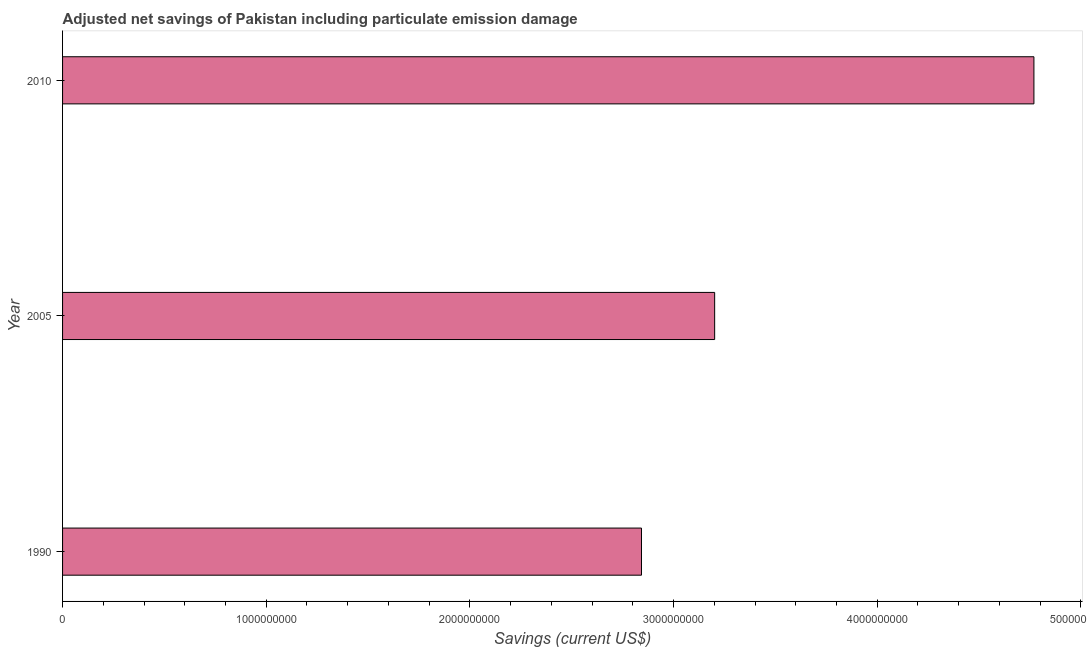Does the graph contain any zero values?
Provide a succinct answer. No. Does the graph contain grids?
Provide a succinct answer. No. What is the title of the graph?
Ensure brevity in your answer.  Adjusted net savings of Pakistan including particulate emission damage. What is the label or title of the X-axis?
Your answer should be very brief. Savings (current US$). What is the adjusted net savings in 2010?
Make the answer very short. 4.77e+09. Across all years, what is the maximum adjusted net savings?
Provide a succinct answer. 4.77e+09. Across all years, what is the minimum adjusted net savings?
Give a very brief answer. 2.84e+09. In which year was the adjusted net savings maximum?
Provide a short and direct response. 2010. What is the sum of the adjusted net savings?
Give a very brief answer. 1.08e+1. What is the difference between the adjusted net savings in 1990 and 2005?
Provide a short and direct response. -3.59e+08. What is the average adjusted net savings per year?
Provide a succinct answer. 3.60e+09. What is the median adjusted net savings?
Give a very brief answer. 3.20e+09. In how many years, is the adjusted net savings greater than 1200000000 US$?
Your answer should be compact. 3. Do a majority of the years between 1990 and 2010 (inclusive) have adjusted net savings greater than 4000000000 US$?
Provide a succinct answer. No. What is the ratio of the adjusted net savings in 1990 to that in 2010?
Your response must be concise. 0.6. Is the difference between the adjusted net savings in 1990 and 2005 greater than the difference between any two years?
Give a very brief answer. No. What is the difference between the highest and the second highest adjusted net savings?
Provide a succinct answer. 1.57e+09. Is the sum of the adjusted net savings in 2005 and 2010 greater than the maximum adjusted net savings across all years?
Your answer should be very brief. Yes. What is the difference between the highest and the lowest adjusted net savings?
Give a very brief answer. 1.93e+09. How many bars are there?
Ensure brevity in your answer.  3. Are the values on the major ticks of X-axis written in scientific E-notation?
Make the answer very short. No. What is the Savings (current US$) in 1990?
Offer a very short reply. 2.84e+09. What is the Savings (current US$) of 2005?
Offer a terse response. 3.20e+09. What is the Savings (current US$) in 2010?
Give a very brief answer. 4.77e+09. What is the difference between the Savings (current US$) in 1990 and 2005?
Make the answer very short. -3.59e+08. What is the difference between the Savings (current US$) in 1990 and 2010?
Your answer should be very brief. -1.93e+09. What is the difference between the Savings (current US$) in 2005 and 2010?
Make the answer very short. -1.57e+09. What is the ratio of the Savings (current US$) in 1990 to that in 2005?
Offer a terse response. 0.89. What is the ratio of the Savings (current US$) in 1990 to that in 2010?
Ensure brevity in your answer.  0.6. What is the ratio of the Savings (current US$) in 2005 to that in 2010?
Provide a short and direct response. 0.67. 